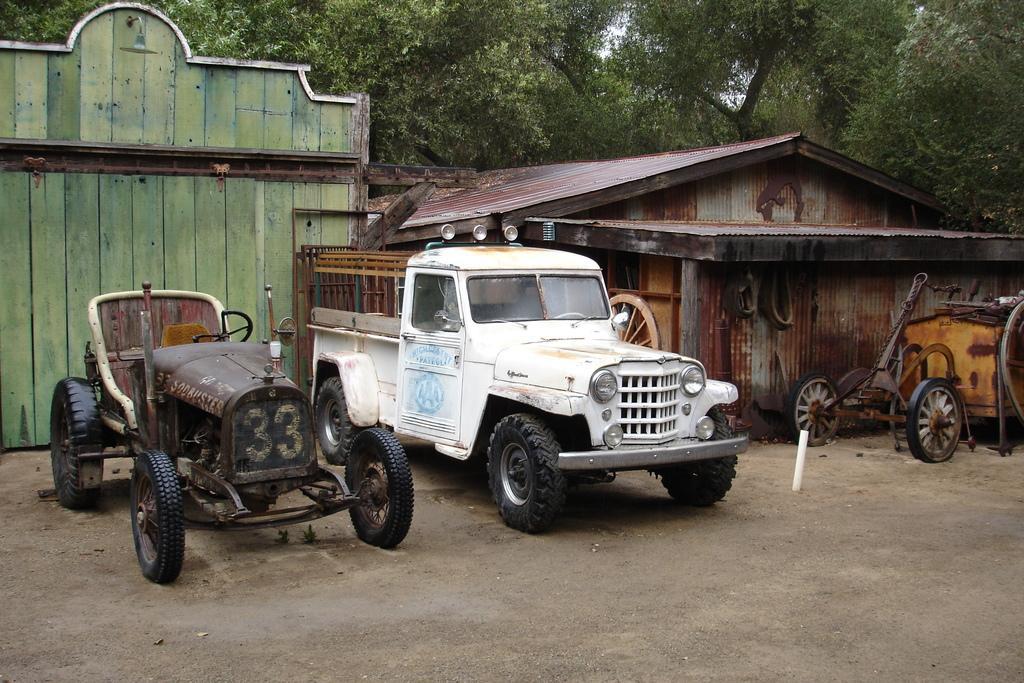Describe this image in one or two sentences. In the center of the image we can see three vehicles. In the background, we can see the sky, trees, one shed, wooden wall and a few other objects. 